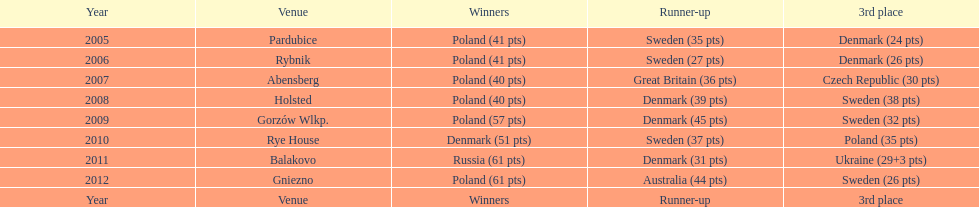When was the first year that poland did not place in the top three positions of the team speedway junior world championship? 2011. Parse the table in full. {'header': ['Year', 'Venue', 'Winners', 'Runner-up', '3rd place'], 'rows': [['2005', 'Pardubice', 'Poland (41 pts)', 'Sweden (35 pts)', 'Denmark (24 pts)'], ['2006', 'Rybnik', 'Poland (41 pts)', 'Sweden (27 pts)', 'Denmark (26 pts)'], ['2007', 'Abensberg', 'Poland (40 pts)', 'Great Britain (36 pts)', 'Czech Republic (30 pts)'], ['2008', 'Holsted', 'Poland (40 pts)', 'Denmark (39 pts)', 'Sweden (38 pts)'], ['2009', 'Gorzów Wlkp.', 'Poland (57 pts)', 'Denmark (45 pts)', 'Sweden (32 pts)'], ['2010', 'Rye House', 'Denmark (51 pts)', 'Sweden (37 pts)', 'Poland (35 pts)'], ['2011', 'Balakovo', 'Russia (61 pts)', 'Denmark (31 pts)', 'Ukraine (29+3 pts)'], ['2012', 'Gniezno', 'Poland (61 pts)', 'Australia (44 pts)', 'Sweden (26 pts)'], ['Year', 'Venue', 'Winners', 'Runner-up', '3rd place']]} 